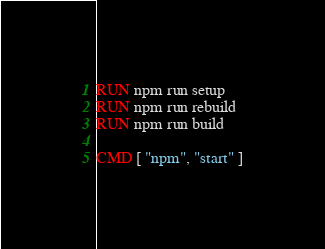<code> <loc_0><loc_0><loc_500><loc_500><_Dockerfile_>
RUN npm run setup
RUN npm run rebuild
RUN npm run build

CMD [ "npm", "start" ]
</code> 